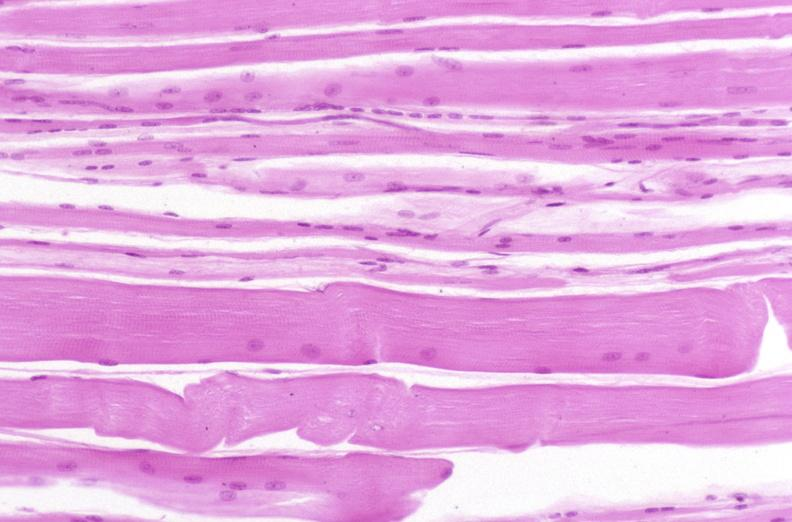why does this image show skeletal muscle, atrophy?
Answer the question using a single word or phrase. Due to immobilization cast 